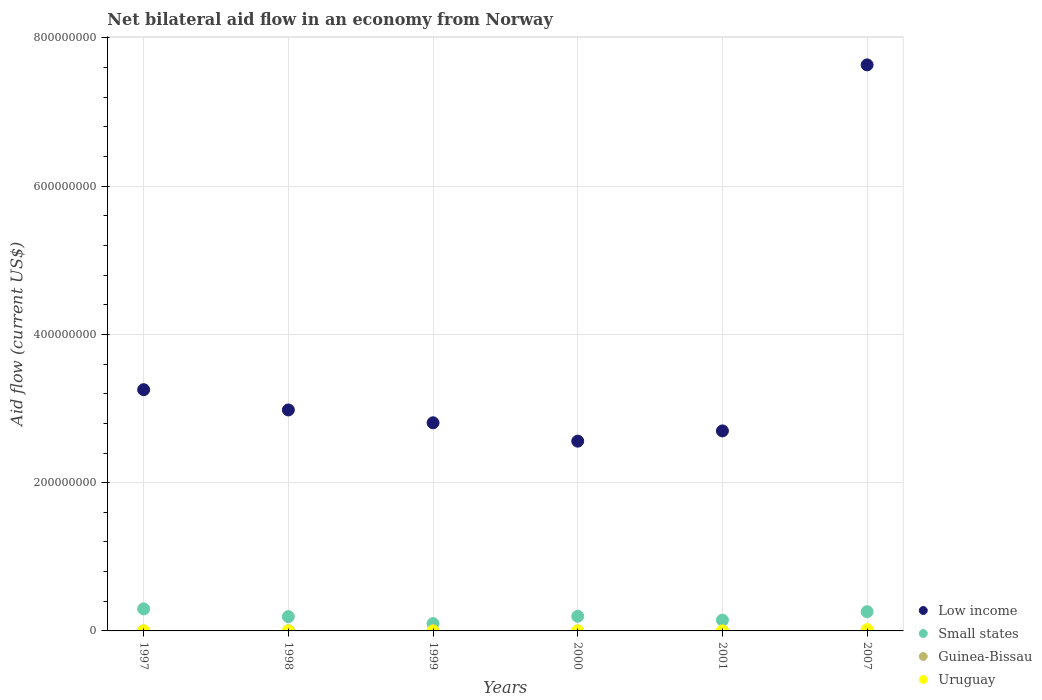How many different coloured dotlines are there?
Offer a terse response. 4. Is the number of dotlines equal to the number of legend labels?
Your response must be concise. Yes. What is the net bilateral aid flow in Low income in 1998?
Offer a terse response. 2.98e+08. Across all years, what is the maximum net bilateral aid flow in Uruguay?
Provide a short and direct response. 1.71e+06. Across all years, what is the minimum net bilateral aid flow in Small states?
Ensure brevity in your answer.  9.85e+06. What is the total net bilateral aid flow in Low income in the graph?
Offer a terse response. 2.19e+09. What is the difference between the net bilateral aid flow in Low income in 1997 and that in 2001?
Offer a terse response. 5.56e+07. What is the difference between the net bilateral aid flow in Low income in 1999 and the net bilateral aid flow in Small states in 2007?
Keep it short and to the point. 2.55e+08. In the year 2007, what is the difference between the net bilateral aid flow in Small states and net bilateral aid flow in Low income?
Provide a succinct answer. -7.38e+08. What is the ratio of the net bilateral aid flow in Uruguay in 1997 to that in 2007?
Ensure brevity in your answer.  0.01. Is the net bilateral aid flow in Small states in 1998 less than that in 2007?
Your answer should be compact. Yes. What is the difference between the highest and the second highest net bilateral aid flow in Small states?
Ensure brevity in your answer.  3.77e+06. What is the difference between the highest and the lowest net bilateral aid flow in Low income?
Provide a short and direct response. 5.08e+08. Is the sum of the net bilateral aid flow in Guinea-Bissau in 2000 and 2007 greater than the maximum net bilateral aid flow in Small states across all years?
Give a very brief answer. No. Is it the case that in every year, the sum of the net bilateral aid flow in Uruguay and net bilateral aid flow in Small states  is greater than the sum of net bilateral aid flow in Guinea-Bissau and net bilateral aid flow in Low income?
Offer a very short reply. No. Is it the case that in every year, the sum of the net bilateral aid flow in Small states and net bilateral aid flow in Low income  is greater than the net bilateral aid flow in Guinea-Bissau?
Offer a terse response. Yes. Is the net bilateral aid flow in Uruguay strictly greater than the net bilateral aid flow in Guinea-Bissau over the years?
Keep it short and to the point. No. How many years are there in the graph?
Your answer should be very brief. 6. What is the difference between two consecutive major ticks on the Y-axis?
Ensure brevity in your answer.  2.00e+08. Are the values on the major ticks of Y-axis written in scientific E-notation?
Your answer should be very brief. No. Does the graph contain any zero values?
Your response must be concise. No. Does the graph contain grids?
Give a very brief answer. Yes. Where does the legend appear in the graph?
Your answer should be compact. Bottom right. How many legend labels are there?
Your answer should be compact. 4. How are the legend labels stacked?
Make the answer very short. Vertical. What is the title of the graph?
Make the answer very short. Net bilateral aid flow in an economy from Norway. What is the label or title of the X-axis?
Give a very brief answer. Years. What is the Aid flow (current US$) in Low income in 1997?
Ensure brevity in your answer.  3.25e+08. What is the Aid flow (current US$) in Small states in 1997?
Your answer should be compact. 2.97e+07. What is the Aid flow (current US$) in Guinea-Bissau in 1997?
Provide a succinct answer. 2.00e+04. What is the Aid flow (current US$) in Uruguay in 1997?
Keep it short and to the point. 2.00e+04. What is the Aid flow (current US$) of Low income in 1998?
Your response must be concise. 2.98e+08. What is the Aid flow (current US$) of Small states in 1998?
Offer a terse response. 1.93e+07. What is the Aid flow (current US$) of Guinea-Bissau in 1998?
Offer a terse response. 3.10e+05. What is the Aid flow (current US$) of Uruguay in 1998?
Provide a succinct answer. 4.00e+04. What is the Aid flow (current US$) in Low income in 1999?
Give a very brief answer. 2.81e+08. What is the Aid flow (current US$) in Small states in 1999?
Provide a succinct answer. 9.85e+06. What is the Aid flow (current US$) of Low income in 2000?
Keep it short and to the point. 2.56e+08. What is the Aid flow (current US$) of Small states in 2000?
Give a very brief answer. 1.97e+07. What is the Aid flow (current US$) in Guinea-Bissau in 2000?
Your response must be concise. 10000. What is the Aid flow (current US$) of Uruguay in 2000?
Provide a short and direct response. 3.00e+04. What is the Aid flow (current US$) in Low income in 2001?
Your answer should be compact. 2.70e+08. What is the Aid flow (current US$) in Small states in 2001?
Provide a succinct answer. 1.45e+07. What is the Aid flow (current US$) in Low income in 2007?
Keep it short and to the point. 7.64e+08. What is the Aid flow (current US$) of Small states in 2007?
Give a very brief answer. 2.60e+07. What is the Aid flow (current US$) of Guinea-Bissau in 2007?
Your response must be concise. 6.90e+05. What is the Aid flow (current US$) in Uruguay in 2007?
Keep it short and to the point. 1.71e+06. Across all years, what is the maximum Aid flow (current US$) of Low income?
Offer a terse response. 7.64e+08. Across all years, what is the maximum Aid flow (current US$) in Small states?
Keep it short and to the point. 2.97e+07. Across all years, what is the maximum Aid flow (current US$) of Guinea-Bissau?
Provide a short and direct response. 6.90e+05. Across all years, what is the maximum Aid flow (current US$) in Uruguay?
Offer a very short reply. 1.71e+06. Across all years, what is the minimum Aid flow (current US$) in Low income?
Make the answer very short. 2.56e+08. Across all years, what is the minimum Aid flow (current US$) of Small states?
Keep it short and to the point. 9.85e+06. Across all years, what is the minimum Aid flow (current US$) of Guinea-Bissau?
Your response must be concise. 10000. Across all years, what is the minimum Aid flow (current US$) of Uruguay?
Make the answer very short. 10000. What is the total Aid flow (current US$) in Low income in the graph?
Make the answer very short. 2.19e+09. What is the total Aid flow (current US$) in Small states in the graph?
Provide a succinct answer. 1.19e+08. What is the total Aid flow (current US$) in Guinea-Bissau in the graph?
Your answer should be very brief. 1.07e+06. What is the total Aid flow (current US$) of Uruguay in the graph?
Your answer should be compact. 1.86e+06. What is the difference between the Aid flow (current US$) of Low income in 1997 and that in 1998?
Offer a very short reply. 2.73e+07. What is the difference between the Aid flow (current US$) in Small states in 1997 and that in 1998?
Keep it short and to the point. 1.04e+07. What is the difference between the Aid flow (current US$) of Low income in 1997 and that in 1999?
Your answer should be very brief. 4.46e+07. What is the difference between the Aid flow (current US$) of Small states in 1997 and that in 1999?
Your response must be concise. 1.99e+07. What is the difference between the Aid flow (current US$) of Guinea-Bissau in 1997 and that in 1999?
Provide a succinct answer. 0. What is the difference between the Aid flow (current US$) of Low income in 1997 and that in 2000?
Offer a very short reply. 6.94e+07. What is the difference between the Aid flow (current US$) in Small states in 1997 and that in 2000?
Keep it short and to the point. 1.00e+07. What is the difference between the Aid flow (current US$) of Low income in 1997 and that in 2001?
Give a very brief answer. 5.56e+07. What is the difference between the Aid flow (current US$) in Small states in 1997 and that in 2001?
Make the answer very short. 1.52e+07. What is the difference between the Aid flow (current US$) of Low income in 1997 and that in 2007?
Make the answer very short. -4.38e+08. What is the difference between the Aid flow (current US$) in Small states in 1997 and that in 2007?
Offer a terse response. 3.77e+06. What is the difference between the Aid flow (current US$) of Guinea-Bissau in 1997 and that in 2007?
Provide a short and direct response. -6.70e+05. What is the difference between the Aid flow (current US$) in Uruguay in 1997 and that in 2007?
Your answer should be compact. -1.69e+06. What is the difference between the Aid flow (current US$) of Low income in 1998 and that in 1999?
Make the answer very short. 1.73e+07. What is the difference between the Aid flow (current US$) of Small states in 1998 and that in 1999?
Your response must be concise. 9.45e+06. What is the difference between the Aid flow (current US$) in Low income in 1998 and that in 2000?
Ensure brevity in your answer.  4.21e+07. What is the difference between the Aid flow (current US$) of Small states in 1998 and that in 2000?
Provide a short and direct response. -4.30e+05. What is the difference between the Aid flow (current US$) of Uruguay in 1998 and that in 2000?
Offer a very short reply. 10000. What is the difference between the Aid flow (current US$) of Low income in 1998 and that in 2001?
Offer a very short reply. 2.83e+07. What is the difference between the Aid flow (current US$) of Small states in 1998 and that in 2001?
Offer a terse response. 4.79e+06. What is the difference between the Aid flow (current US$) of Guinea-Bissau in 1998 and that in 2001?
Offer a terse response. 2.90e+05. What is the difference between the Aid flow (current US$) in Low income in 1998 and that in 2007?
Offer a terse response. -4.66e+08. What is the difference between the Aid flow (current US$) in Small states in 1998 and that in 2007?
Keep it short and to the point. -6.67e+06. What is the difference between the Aid flow (current US$) of Guinea-Bissau in 1998 and that in 2007?
Provide a short and direct response. -3.80e+05. What is the difference between the Aid flow (current US$) in Uruguay in 1998 and that in 2007?
Keep it short and to the point. -1.67e+06. What is the difference between the Aid flow (current US$) in Low income in 1999 and that in 2000?
Give a very brief answer. 2.48e+07. What is the difference between the Aid flow (current US$) of Small states in 1999 and that in 2000?
Your answer should be very brief. -9.88e+06. What is the difference between the Aid flow (current US$) in Guinea-Bissau in 1999 and that in 2000?
Keep it short and to the point. 10000. What is the difference between the Aid flow (current US$) in Uruguay in 1999 and that in 2000?
Your answer should be compact. 2.00e+04. What is the difference between the Aid flow (current US$) of Low income in 1999 and that in 2001?
Your answer should be compact. 1.10e+07. What is the difference between the Aid flow (current US$) of Small states in 1999 and that in 2001?
Your answer should be compact. -4.66e+06. What is the difference between the Aid flow (current US$) in Guinea-Bissau in 1999 and that in 2001?
Provide a short and direct response. 0. What is the difference between the Aid flow (current US$) of Uruguay in 1999 and that in 2001?
Your response must be concise. 4.00e+04. What is the difference between the Aid flow (current US$) in Low income in 1999 and that in 2007?
Make the answer very short. -4.83e+08. What is the difference between the Aid flow (current US$) in Small states in 1999 and that in 2007?
Your answer should be very brief. -1.61e+07. What is the difference between the Aid flow (current US$) in Guinea-Bissau in 1999 and that in 2007?
Provide a succinct answer. -6.70e+05. What is the difference between the Aid flow (current US$) in Uruguay in 1999 and that in 2007?
Keep it short and to the point. -1.66e+06. What is the difference between the Aid flow (current US$) of Low income in 2000 and that in 2001?
Keep it short and to the point. -1.38e+07. What is the difference between the Aid flow (current US$) of Small states in 2000 and that in 2001?
Your response must be concise. 5.22e+06. What is the difference between the Aid flow (current US$) of Uruguay in 2000 and that in 2001?
Make the answer very short. 2.00e+04. What is the difference between the Aid flow (current US$) in Low income in 2000 and that in 2007?
Your answer should be compact. -5.08e+08. What is the difference between the Aid flow (current US$) of Small states in 2000 and that in 2007?
Ensure brevity in your answer.  -6.24e+06. What is the difference between the Aid flow (current US$) in Guinea-Bissau in 2000 and that in 2007?
Offer a terse response. -6.80e+05. What is the difference between the Aid flow (current US$) in Uruguay in 2000 and that in 2007?
Offer a very short reply. -1.68e+06. What is the difference between the Aid flow (current US$) of Low income in 2001 and that in 2007?
Give a very brief answer. -4.94e+08. What is the difference between the Aid flow (current US$) of Small states in 2001 and that in 2007?
Keep it short and to the point. -1.15e+07. What is the difference between the Aid flow (current US$) of Guinea-Bissau in 2001 and that in 2007?
Your response must be concise. -6.70e+05. What is the difference between the Aid flow (current US$) of Uruguay in 2001 and that in 2007?
Give a very brief answer. -1.70e+06. What is the difference between the Aid flow (current US$) of Low income in 1997 and the Aid flow (current US$) of Small states in 1998?
Your answer should be compact. 3.06e+08. What is the difference between the Aid flow (current US$) in Low income in 1997 and the Aid flow (current US$) in Guinea-Bissau in 1998?
Keep it short and to the point. 3.25e+08. What is the difference between the Aid flow (current US$) of Low income in 1997 and the Aid flow (current US$) of Uruguay in 1998?
Make the answer very short. 3.25e+08. What is the difference between the Aid flow (current US$) in Small states in 1997 and the Aid flow (current US$) in Guinea-Bissau in 1998?
Provide a succinct answer. 2.94e+07. What is the difference between the Aid flow (current US$) in Small states in 1997 and the Aid flow (current US$) in Uruguay in 1998?
Your response must be concise. 2.97e+07. What is the difference between the Aid flow (current US$) in Low income in 1997 and the Aid flow (current US$) in Small states in 1999?
Provide a short and direct response. 3.16e+08. What is the difference between the Aid flow (current US$) in Low income in 1997 and the Aid flow (current US$) in Guinea-Bissau in 1999?
Provide a succinct answer. 3.25e+08. What is the difference between the Aid flow (current US$) in Low income in 1997 and the Aid flow (current US$) in Uruguay in 1999?
Make the answer very short. 3.25e+08. What is the difference between the Aid flow (current US$) in Small states in 1997 and the Aid flow (current US$) in Guinea-Bissau in 1999?
Offer a terse response. 2.97e+07. What is the difference between the Aid flow (current US$) of Small states in 1997 and the Aid flow (current US$) of Uruguay in 1999?
Offer a terse response. 2.97e+07. What is the difference between the Aid flow (current US$) in Low income in 1997 and the Aid flow (current US$) in Small states in 2000?
Provide a succinct answer. 3.06e+08. What is the difference between the Aid flow (current US$) of Low income in 1997 and the Aid flow (current US$) of Guinea-Bissau in 2000?
Ensure brevity in your answer.  3.25e+08. What is the difference between the Aid flow (current US$) of Low income in 1997 and the Aid flow (current US$) of Uruguay in 2000?
Provide a succinct answer. 3.25e+08. What is the difference between the Aid flow (current US$) of Small states in 1997 and the Aid flow (current US$) of Guinea-Bissau in 2000?
Give a very brief answer. 2.97e+07. What is the difference between the Aid flow (current US$) of Small states in 1997 and the Aid flow (current US$) of Uruguay in 2000?
Offer a terse response. 2.97e+07. What is the difference between the Aid flow (current US$) in Low income in 1997 and the Aid flow (current US$) in Small states in 2001?
Offer a very short reply. 3.11e+08. What is the difference between the Aid flow (current US$) of Low income in 1997 and the Aid flow (current US$) of Guinea-Bissau in 2001?
Give a very brief answer. 3.25e+08. What is the difference between the Aid flow (current US$) of Low income in 1997 and the Aid flow (current US$) of Uruguay in 2001?
Offer a very short reply. 3.25e+08. What is the difference between the Aid flow (current US$) of Small states in 1997 and the Aid flow (current US$) of Guinea-Bissau in 2001?
Offer a terse response. 2.97e+07. What is the difference between the Aid flow (current US$) of Small states in 1997 and the Aid flow (current US$) of Uruguay in 2001?
Keep it short and to the point. 2.97e+07. What is the difference between the Aid flow (current US$) of Low income in 1997 and the Aid flow (current US$) of Small states in 2007?
Keep it short and to the point. 3.00e+08. What is the difference between the Aid flow (current US$) of Low income in 1997 and the Aid flow (current US$) of Guinea-Bissau in 2007?
Your answer should be compact. 3.25e+08. What is the difference between the Aid flow (current US$) of Low income in 1997 and the Aid flow (current US$) of Uruguay in 2007?
Your answer should be compact. 3.24e+08. What is the difference between the Aid flow (current US$) in Small states in 1997 and the Aid flow (current US$) in Guinea-Bissau in 2007?
Your response must be concise. 2.90e+07. What is the difference between the Aid flow (current US$) in Small states in 1997 and the Aid flow (current US$) in Uruguay in 2007?
Provide a succinct answer. 2.80e+07. What is the difference between the Aid flow (current US$) in Guinea-Bissau in 1997 and the Aid flow (current US$) in Uruguay in 2007?
Your response must be concise. -1.69e+06. What is the difference between the Aid flow (current US$) of Low income in 1998 and the Aid flow (current US$) of Small states in 1999?
Your response must be concise. 2.88e+08. What is the difference between the Aid flow (current US$) in Low income in 1998 and the Aid flow (current US$) in Guinea-Bissau in 1999?
Offer a terse response. 2.98e+08. What is the difference between the Aid flow (current US$) of Low income in 1998 and the Aid flow (current US$) of Uruguay in 1999?
Make the answer very short. 2.98e+08. What is the difference between the Aid flow (current US$) of Small states in 1998 and the Aid flow (current US$) of Guinea-Bissau in 1999?
Your answer should be very brief. 1.93e+07. What is the difference between the Aid flow (current US$) of Small states in 1998 and the Aid flow (current US$) of Uruguay in 1999?
Your response must be concise. 1.92e+07. What is the difference between the Aid flow (current US$) in Guinea-Bissau in 1998 and the Aid flow (current US$) in Uruguay in 1999?
Offer a terse response. 2.60e+05. What is the difference between the Aid flow (current US$) in Low income in 1998 and the Aid flow (current US$) in Small states in 2000?
Ensure brevity in your answer.  2.78e+08. What is the difference between the Aid flow (current US$) of Low income in 1998 and the Aid flow (current US$) of Guinea-Bissau in 2000?
Offer a very short reply. 2.98e+08. What is the difference between the Aid flow (current US$) of Low income in 1998 and the Aid flow (current US$) of Uruguay in 2000?
Provide a succinct answer. 2.98e+08. What is the difference between the Aid flow (current US$) in Small states in 1998 and the Aid flow (current US$) in Guinea-Bissau in 2000?
Make the answer very short. 1.93e+07. What is the difference between the Aid flow (current US$) of Small states in 1998 and the Aid flow (current US$) of Uruguay in 2000?
Make the answer very short. 1.93e+07. What is the difference between the Aid flow (current US$) of Guinea-Bissau in 1998 and the Aid flow (current US$) of Uruguay in 2000?
Ensure brevity in your answer.  2.80e+05. What is the difference between the Aid flow (current US$) of Low income in 1998 and the Aid flow (current US$) of Small states in 2001?
Your response must be concise. 2.84e+08. What is the difference between the Aid flow (current US$) in Low income in 1998 and the Aid flow (current US$) in Guinea-Bissau in 2001?
Your response must be concise. 2.98e+08. What is the difference between the Aid flow (current US$) of Low income in 1998 and the Aid flow (current US$) of Uruguay in 2001?
Ensure brevity in your answer.  2.98e+08. What is the difference between the Aid flow (current US$) of Small states in 1998 and the Aid flow (current US$) of Guinea-Bissau in 2001?
Provide a short and direct response. 1.93e+07. What is the difference between the Aid flow (current US$) in Small states in 1998 and the Aid flow (current US$) in Uruguay in 2001?
Offer a very short reply. 1.93e+07. What is the difference between the Aid flow (current US$) of Guinea-Bissau in 1998 and the Aid flow (current US$) of Uruguay in 2001?
Provide a short and direct response. 3.00e+05. What is the difference between the Aid flow (current US$) in Low income in 1998 and the Aid flow (current US$) in Small states in 2007?
Ensure brevity in your answer.  2.72e+08. What is the difference between the Aid flow (current US$) of Low income in 1998 and the Aid flow (current US$) of Guinea-Bissau in 2007?
Provide a short and direct response. 2.97e+08. What is the difference between the Aid flow (current US$) in Low income in 1998 and the Aid flow (current US$) in Uruguay in 2007?
Make the answer very short. 2.96e+08. What is the difference between the Aid flow (current US$) in Small states in 1998 and the Aid flow (current US$) in Guinea-Bissau in 2007?
Offer a very short reply. 1.86e+07. What is the difference between the Aid flow (current US$) of Small states in 1998 and the Aid flow (current US$) of Uruguay in 2007?
Offer a very short reply. 1.76e+07. What is the difference between the Aid flow (current US$) in Guinea-Bissau in 1998 and the Aid flow (current US$) in Uruguay in 2007?
Ensure brevity in your answer.  -1.40e+06. What is the difference between the Aid flow (current US$) of Low income in 1999 and the Aid flow (current US$) of Small states in 2000?
Provide a short and direct response. 2.61e+08. What is the difference between the Aid flow (current US$) in Low income in 1999 and the Aid flow (current US$) in Guinea-Bissau in 2000?
Offer a terse response. 2.81e+08. What is the difference between the Aid flow (current US$) in Low income in 1999 and the Aid flow (current US$) in Uruguay in 2000?
Offer a very short reply. 2.81e+08. What is the difference between the Aid flow (current US$) in Small states in 1999 and the Aid flow (current US$) in Guinea-Bissau in 2000?
Your answer should be very brief. 9.84e+06. What is the difference between the Aid flow (current US$) of Small states in 1999 and the Aid flow (current US$) of Uruguay in 2000?
Offer a terse response. 9.82e+06. What is the difference between the Aid flow (current US$) of Guinea-Bissau in 1999 and the Aid flow (current US$) of Uruguay in 2000?
Offer a very short reply. -10000. What is the difference between the Aid flow (current US$) in Low income in 1999 and the Aid flow (current US$) in Small states in 2001?
Your answer should be compact. 2.66e+08. What is the difference between the Aid flow (current US$) of Low income in 1999 and the Aid flow (current US$) of Guinea-Bissau in 2001?
Provide a succinct answer. 2.81e+08. What is the difference between the Aid flow (current US$) of Low income in 1999 and the Aid flow (current US$) of Uruguay in 2001?
Your answer should be very brief. 2.81e+08. What is the difference between the Aid flow (current US$) in Small states in 1999 and the Aid flow (current US$) in Guinea-Bissau in 2001?
Provide a succinct answer. 9.83e+06. What is the difference between the Aid flow (current US$) of Small states in 1999 and the Aid flow (current US$) of Uruguay in 2001?
Provide a short and direct response. 9.84e+06. What is the difference between the Aid flow (current US$) in Low income in 1999 and the Aid flow (current US$) in Small states in 2007?
Ensure brevity in your answer.  2.55e+08. What is the difference between the Aid flow (current US$) in Low income in 1999 and the Aid flow (current US$) in Guinea-Bissau in 2007?
Ensure brevity in your answer.  2.80e+08. What is the difference between the Aid flow (current US$) in Low income in 1999 and the Aid flow (current US$) in Uruguay in 2007?
Provide a short and direct response. 2.79e+08. What is the difference between the Aid flow (current US$) in Small states in 1999 and the Aid flow (current US$) in Guinea-Bissau in 2007?
Give a very brief answer. 9.16e+06. What is the difference between the Aid flow (current US$) in Small states in 1999 and the Aid flow (current US$) in Uruguay in 2007?
Your answer should be compact. 8.14e+06. What is the difference between the Aid flow (current US$) of Guinea-Bissau in 1999 and the Aid flow (current US$) of Uruguay in 2007?
Give a very brief answer. -1.69e+06. What is the difference between the Aid flow (current US$) in Low income in 2000 and the Aid flow (current US$) in Small states in 2001?
Keep it short and to the point. 2.42e+08. What is the difference between the Aid flow (current US$) of Low income in 2000 and the Aid flow (current US$) of Guinea-Bissau in 2001?
Your answer should be compact. 2.56e+08. What is the difference between the Aid flow (current US$) of Low income in 2000 and the Aid flow (current US$) of Uruguay in 2001?
Ensure brevity in your answer.  2.56e+08. What is the difference between the Aid flow (current US$) in Small states in 2000 and the Aid flow (current US$) in Guinea-Bissau in 2001?
Give a very brief answer. 1.97e+07. What is the difference between the Aid flow (current US$) in Small states in 2000 and the Aid flow (current US$) in Uruguay in 2001?
Ensure brevity in your answer.  1.97e+07. What is the difference between the Aid flow (current US$) of Guinea-Bissau in 2000 and the Aid flow (current US$) of Uruguay in 2001?
Give a very brief answer. 0. What is the difference between the Aid flow (current US$) in Low income in 2000 and the Aid flow (current US$) in Small states in 2007?
Your response must be concise. 2.30e+08. What is the difference between the Aid flow (current US$) in Low income in 2000 and the Aid flow (current US$) in Guinea-Bissau in 2007?
Offer a very short reply. 2.55e+08. What is the difference between the Aid flow (current US$) in Low income in 2000 and the Aid flow (current US$) in Uruguay in 2007?
Give a very brief answer. 2.54e+08. What is the difference between the Aid flow (current US$) of Small states in 2000 and the Aid flow (current US$) of Guinea-Bissau in 2007?
Make the answer very short. 1.90e+07. What is the difference between the Aid flow (current US$) of Small states in 2000 and the Aid flow (current US$) of Uruguay in 2007?
Offer a terse response. 1.80e+07. What is the difference between the Aid flow (current US$) of Guinea-Bissau in 2000 and the Aid flow (current US$) of Uruguay in 2007?
Provide a short and direct response. -1.70e+06. What is the difference between the Aid flow (current US$) of Low income in 2001 and the Aid flow (current US$) of Small states in 2007?
Ensure brevity in your answer.  2.44e+08. What is the difference between the Aid flow (current US$) of Low income in 2001 and the Aid flow (current US$) of Guinea-Bissau in 2007?
Your answer should be compact. 2.69e+08. What is the difference between the Aid flow (current US$) of Low income in 2001 and the Aid flow (current US$) of Uruguay in 2007?
Offer a terse response. 2.68e+08. What is the difference between the Aid flow (current US$) in Small states in 2001 and the Aid flow (current US$) in Guinea-Bissau in 2007?
Offer a terse response. 1.38e+07. What is the difference between the Aid flow (current US$) of Small states in 2001 and the Aid flow (current US$) of Uruguay in 2007?
Keep it short and to the point. 1.28e+07. What is the difference between the Aid flow (current US$) of Guinea-Bissau in 2001 and the Aid flow (current US$) of Uruguay in 2007?
Your answer should be very brief. -1.69e+06. What is the average Aid flow (current US$) of Low income per year?
Provide a succinct answer. 3.66e+08. What is the average Aid flow (current US$) in Small states per year?
Provide a succinct answer. 1.98e+07. What is the average Aid flow (current US$) in Guinea-Bissau per year?
Offer a very short reply. 1.78e+05. What is the average Aid flow (current US$) in Uruguay per year?
Provide a short and direct response. 3.10e+05. In the year 1997, what is the difference between the Aid flow (current US$) of Low income and Aid flow (current US$) of Small states?
Make the answer very short. 2.96e+08. In the year 1997, what is the difference between the Aid flow (current US$) of Low income and Aid flow (current US$) of Guinea-Bissau?
Make the answer very short. 3.25e+08. In the year 1997, what is the difference between the Aid flow (current US$) of Low income and Aid flow (current US$) of Uruguay?
Provide a short and direct response. 3.25e+08. In the year 1997, what is the difference between the Aid flow (current US$) of Small states and Aid flow (current US$) of Guinea-Bissau?
Keep it short and to the point. 2.97e+07. In the year 1997, what is the difference between the Aid flow (current US$) in Small states and Aid flow (current US$) in Uruguay?
Your response must be concise. 2.97e+07. In the year 1997, what is the difference between the Aid flow (current US$) in Guinea-Bissau and Aid flow (current US$) in Uruguay?
Provide a succinct answer. 0. In the year 1998, what is the difference between the Aid flow (current US$) of Low income and Aid flow (current US$) of Small states?
Give a very brief answer. 2.79e+08. In the year 1998, what is the difference between the Aid flow (current US$) of Low income and Aid flow (current US$) of Guinea-Bissau?
Offer a terse response. 2.98e+08. In the year 1998, what is the difference between the Aid flow (current US$) of Low income and Aid flow (current US$) of Uruguay?
Ensure brevity in your answer.  2.98e+08. In the year 1998, what is the difference between the Aid flow (current US$) in Small states and Aid flow (current US$) in Guinea-Bissau?
Offer a terse response. 1.90e+07. In the year 1998, what is the difference between the Aid flow (current US$) in Small states and Aid flow (current US$) in Uruguay?
Make the answer very short. 1.93e+07. In the year 1999, what is the difference between the Aid flow (current US$) in Low income and Aid flow (current US$) in Small states?
Make the answer very short. 2.71e+08. In the year 1999, what is the difference between the Aid flow (current US$) in Low income and Aid flow (current US$) in Guinea-Bissau?
Ensure brevity in your answer.  2.81e+08. In the year 1999, what is the difference between the Aid flow (current US$) of Low income and Aid flow (current US$) of Uruguay?
Your answer should be very brief. 2.81e+08. In the year 1999, what is the difference between the Aid flow (current US$) of Small states and Aid flow (current US$) of Guinea-Bissau?
Give a very brief answer. 9.83e+06. In the year 1999, what is the difference between the Aid flow (current US$) of Small states and Aid flow (current US$) of Uruguay?
Your answer should be compact. 9.80e+06. In the year 1999, what is the difference between the Aid flow (current US$) in Guinea-Bissau and Aid flow (current US$) in Uruguay?
Offer a terse response. -3.00e+04. In the year 2000, what is the difference between the Aid flow (current US$) in Low income and Aid flow (current US$) in Small states?
Ensure brevity in your answer.  2.36e+08. In the year 2000, what is the difference between the Aid flow (current US$) of Low income and Aid flow (current US$) of Guinea-Bissau?
Offer a terse response. 2.56e+08. In the year 2000, what is the difference between the Aid flow (current US$) in Low income and Aid flow (current US$) in Uruguay?
Ensure brevity in your answer.  2.56e+08. In the year 2000, what is the difference between the Aid flow (current US$) in Small states and Aid flow (current US$) in Guinea-Bissau?
Keep it short and to the point. 1.97e+07. In the year 2000, what is the difference between the Aid flow (current US$) in Small states and Aid flow (current US$) in Uruguay?
Your answer should be very brief. 1.97e+07. In the year 2001, what is the difference between the Aid flow (current US$) in Low income and Aid flow (current US$) in Small states?
Your response must be concise. 2.55e+08. In the year 2001, what is the difference between the Aid flow (current US$) in Low income and Aid flow (current US$) in Guinea-Bissau?
Give a very brief answer. 2.70e+08. In the year 2001, what is the difference between the Aid flow (current US$) in Low income and Aid flow (current US$) in Uruguay?
Your answer should be compact. 2.70e+08. In the year 2001, what is the difference between the Aid flow (current US$) of Small states and Aid flow (current US$) of Guinea-Bissau?
Your answer should be compact. 1.45e+07. In the year 2001, what is the difference between the Aid flow (current US$) of Small states and Aid flow (current US$) of Uruguay?
Your answer should be compact. 1.45e+07. In the year 2007, what is the difference between the Aid flow (current US$) of Low income and Aid flow (current US$) of Small states?
Provide a succinct answer. 7.38e+08. In the year 2007, what is the difference between the Aid flow (current US$) of Low income and Aid flow (current US$) of Guinea-Bissau?
Your response must be concise. 7.63e+08. In the year 2007, what is the difference between the Aid flow (current US$) of Low income and Aid flow (current US$) of Uruguay?
Your answer should be compact. 7.62e+08. In the year 2007, what is the difference between the Aid flow (current US$) of Small states and Aid flow (current US$) of Guinea-Bissau?
Your response must be concise. 2.53e+07. In the year 2007, what is the difference between the Aid flow (current US$) in Small states and Aid flow (current US$) in Uruguay?
Your response must be concise. 2.43e+07. In the year 2007, what is the difference between the Aid flow (current US$) of Guinea-Bissau and Aid flow (current US$) of Uruguay?
Make the answer very short. -1.02e+06. What is the ratio of the Aid flow (current US$) of Low income in 1997 to that in 1998?
Your answer should be very brief. 1.09. What is the ratio of the Aid flow (current US$) in Small states in 1997 to that in 1998?
Make the answer very short. 1.54. What is the ratio of the Aid flow (current US$) in Guinea-Bissau in 1997 to that in 1998?
Your answer should be compact. 0.06. What is the ratio of the Aid flow (current US$) of Low income in 1997 to that in 1999?
Give a very brief answer. 1.16. What is the ratio of the Aid flow (current US$) of Small states in 1997 to that in 1999?
Offer a terse response. 3.02. What is the ratio of the Aid flow (current US$) of Guinea-Bissau in 1997 to that in 1999?
Ensure brevity in your answer.  1. What is the ratio of the Aid flow (current US$) in Uruguay in 1997 to that in 1999?
Offer a very short reply. 0.4. What is the ratio of the Aid flow (current US$) of Low income in 1997 to that in 2000?
Provide a succinct answer. 1.27. What is the ratio of the Aid flow (current US$) in Small states in 1997 to that in 2000?
Make the answer very short. 1.51. What is the ratio of the Aid flow (current US$) of Uruguay in 1997 to that in 2000?
Your response must be concise. 0.67. What is the ratio of the Aid flow (current US$) of Low income in 1997 to that in 2001?
Your answer should be compact. 1.21. What is the ratio of the Aid flow (current US$) of Small states in 1997 to that in 2001?
Provide a succinct answer. 2.05. What is the ratio of the Aid flow (current US$) of Uruguay in 1997 to that in 2001?
Give a very brief answer. 2. What is the ratio of the Aid flow (current US$) of Low income in 1997 to that in 2007?
Your answer should be compact. 0.43. What is the ratio of the Aid flow (current US$) in Small states in 1997 to that in 2007?
Provide a succinct answer. 1.15. What is the ratio of the Aid flow (current US$) of Guinea-Bissau in 1997 to that in 2007?
Ensure brevity in your answer.  0.03. What is the ratio of the Aid flow (current US$) in Uruguay in 1997 to that in 2007?
Provide a succinct answer. 0.01. What is the ratio of the Aid flow (current US$) in Low income in 1998 to that in 1999?
Give a very brief answer. 1.06. What is the ratio of the Aid flow (current US$) of Small states in 1998 to that in 1999?
Your answer should be very brief. 1.96. What is the ratio of the Aid flow (current US$) of Guinea-Bissau in 1998 to that in 1999?
Your response must be concise. 15.5. What is the ratio of the Aid flow (current US$) in Uruguay in 1998 to that in 1999?
Keep it short and to the point. 0.8. What is the ratio of the Aid flow (current US$) in Low income in 1998 to that in 2000?
Your answer should be very brief. 1.16. What is the ratio of the Aid flow (current US$) in Small states in 1998 to that in 2000?
Give a very brief answer. 0.98. What is the ratio of the Aid flow (current US$) in Uruguay in 1998 to that in 2000?
Offer a terse response. 1.33. What is the ratio of the Aid flow (current US$) of Low income in 1998 to that in 2001?
Offer a terse response. 1.1. What is the ratio of the Aid flow (current US$) in Small states in 1998 to that in 2001?
Make the answer very short. 1.33. What is the ratio of the Aid flow (current US$) of Guinea-Bissau in 1998 to that in 2001?
Provide a short and direct response. 15.5. What is the ratio of the Aid flow (current US$) of Low income in 1998 to that in 2007?
Make the answer very short. 0.39. What is the ratio of the Aid flow (current US$) in Small states in 1998 to that in 2007?
Offer a very short reply. 0.74. What is the ratio of the Aid flow (current US$) in Guinea-Bissau in 1998 to that in 2007?
Offer a terse response. 0.45. What is the ratio of the Aid flow (current US$) of Uruguay in 1998 to that in 2007?
Offer a terse response. 0.02. What is the ratio of the Aid flow (current US$) of Low income in 1999 to that in 2000?
Give a very brief answer. 1.1. What is the ratio of the Aid flow (current US$) in Small states in 1999 to that in 2000?
Give a very brief answer. 0.5. What is the ratio of the Aid flow (current US$) of Guinea-Bissau in 1999 to that in 2000?
Provide a short and direct response. 2. What is the ratio of the Aid flow (current US$) of Low income in 1999 to that in 2001?
Offer a very short reply. 1.04. What is the ratio of the Aid flow (current US$) in Small states in 1999 to that in 2001?
Keep it short and to the point. 0.68. What is the ratio of the Aid flow (current US$) in Guinea-Bissau in 1999 to that in 2001?
Offer a very short reply. 1. What is the ratio of the Aid flow (current US$) of Low income in 1999 to that in 2007?
Offer a very short reply. 0.37. What is the ratio of the Aid flow (current US$) of Small states in 1999 to that in 2007?
Keep it short and to the point. 0.38. What is the ratio of the Aid flow (current US$) in Guinea-Bissau in 1999 to that in 2007?
Ensure brevity in your answer.  0.03. What is the ratio of the Aid flow (current US$) of Uruguay in 1999 to that in 2007?
Your response must be concise. 0.03. What is the ratio of the Aid flow (current US$) in Low income in 2000 to that in 2001?
Offer a very short reply. 0.95. What is the ratio of the Aid flow (current US$) in Small states in 2000 to that in 2001?
Your answer should be very brief. 1.36. What is the ratio of the Aid flow (current US$) of Low income in 2000 to that in 2007?
Offer a terse response. 0.34. What is the ratio of the Aid flow (current US$) in Small states in 2000 to that in 2007?
Ensure brevity in your answer.  0.76. What is the ratio of the Aid flow (current US$) of Guinea-Bissau in 2000 to that in 2007?
Your answer should be compact. 0.01. What is the ratio of the Aid flow (current US$) in Uruguay in 2000 to that in 2007?
Ensure brevity in your answer.  0.02. What is the ratio of the Aid flow (current US$) in Low income in 2001 to that in 2007?
Provide a succinct answer. 0.35. What is the ratio of the Aid flow (current US$) of Small states in 2001 to that in 2007?
Offer a very short reply. 0.56. What is the ratio of the Aid flow (current US$) of Guinea-Bissau in 2001 to that in 2007?
Your response must be concise. 0.03. What is the ratio of the Aid flow (current US$) of Uruguay in 2001 to that in 2007?
Offer a very short reply. 0.01. What is the difference between the highest and the second highest Aid flow (current US$) of Low income?
Ensure brevity in your answer.  4.38e+08. What is the difference between the highest and the second highest Aid flow (current US$) of Small states?
Give a very brief answer. 3.77e+06. What is the difference between the highest and the second highest Aid flow (current US$) in Uruguay?
Offer a very short reply. 1.66e+06. What is the difference between the highest and the lowest Aid flow (current US$) in Low income?
Provide a short and direct response. 5.08e+08. What is the difference between the highest and the lowest Aid flow (current US$) of Small states?
Offer a terse response. 1.99e+07. What is the difference between the highest and the lowest Aid flow (current US$) of Guinea-Bissau?
Provide a succinct answer. 6.80e+05. What is the difference between the highest and the lowest Aid flow (current US$) in Uruguay?
Offer a terse response. 1.70e+06. 